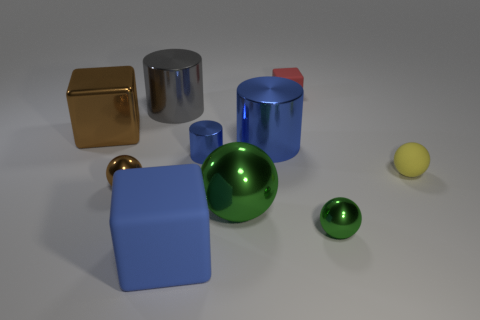Subtract all brown spheres. How many spheres are left? 3 Subtract 2 spheres. How many spheres are left? 2 Subtract all red blocks. How many blocks are left? 2 Subtract all cylinders. How many objects are left? 7 Subtract all gray balls. Subtract all green cubes. How many balls are left? 4 Subtract all green blocks. How many yellow spheres are left? 1 Subtract all gray metal cylinders. Subtract all red things. How many objects are left? 8 Add 1 brown shiny things. How many brown shiny things are left? 3 Add 4 big blue matte things. How many big blue matte things exist? 5 Subtract 1 red cubes. How many objects are left? 9 